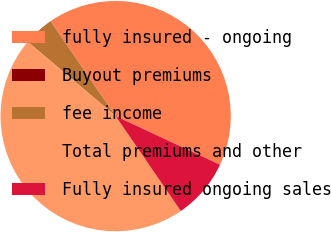<chart> <loc_0><loc_0><loc_500><loc_500><pie_chart><fcel>fully insured - ongoing<fcel>Buyout premiums<fcel>fee income<fcel>Total premiums and other<fcel>Fully insured ongoing sales<nl><fcel>41.5%<fcel>0.01%<fcel>4.25%<fcel>45.74%<fcel>8.49%<nl></chart> 